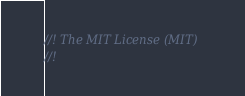<code> <loc_0><loc_0><loc_500><loc_500><_C++_>//! The MIT License (MIT)
//!</code> 